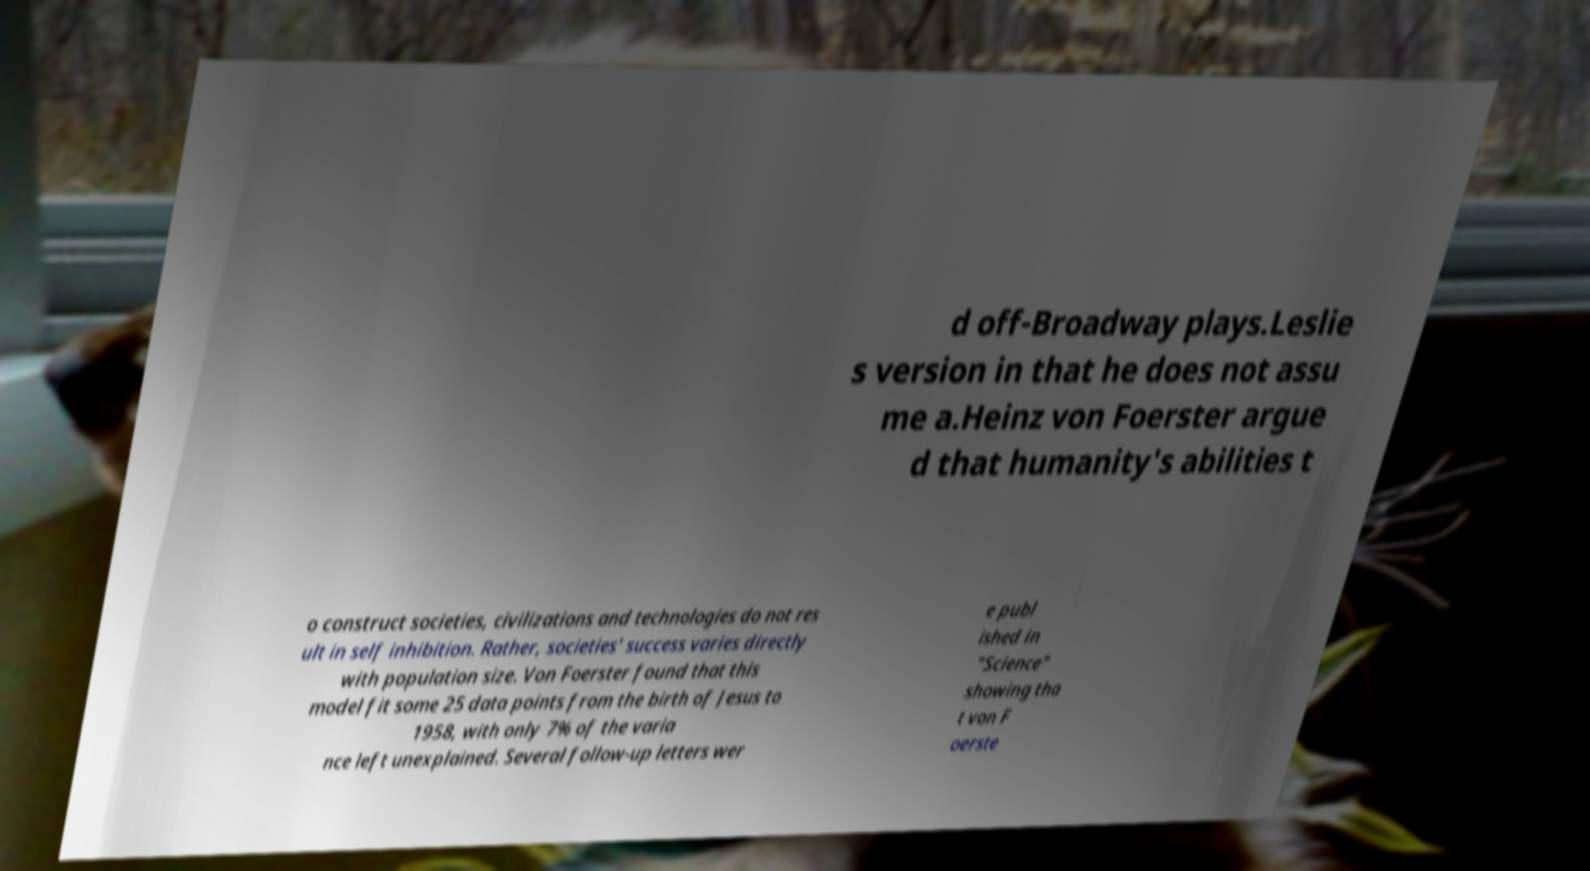Please identify and transcribe the text found in this image. d off-Broadway plays.Leslie s version in that he does not assu me a.Heinz von Foerster argue d that humanity's abilities t o construct societies, civilizations and technologies do not res ult in self inhibition. Rather, societies' success varies directly with population size. Von Foerster found that this model fit some 25 data points from the birth of Jesus to 1958, with only 7% of the varia nce left unexplained. Several follow-up letters wer e publ ished in "Science" showing tha t von F oerste 